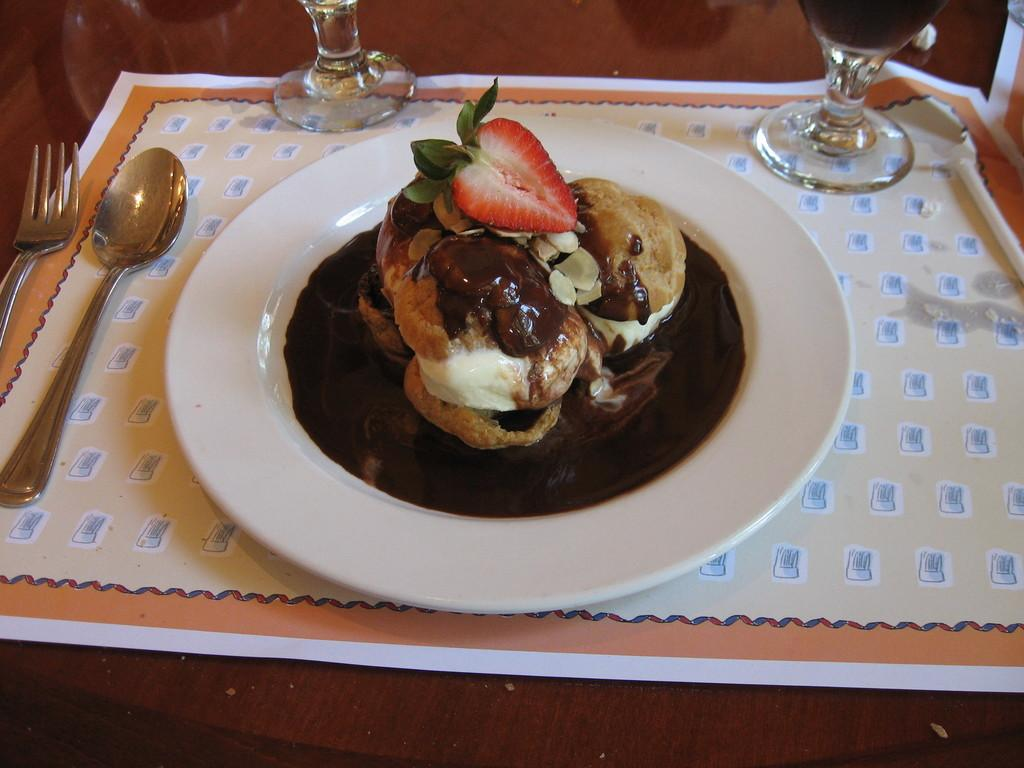What piece of furniture is present in the image? There is a table in the image. What items can be seen on the table? There are glasses, spoons, and a plate on the table. What is on the plate? There is a dish on the plate. What type of can is visible on the table in the image? There is no can present on the table in the image. What material is the linen made of that is draped over the table? There is no linen draped over the table in the image. 